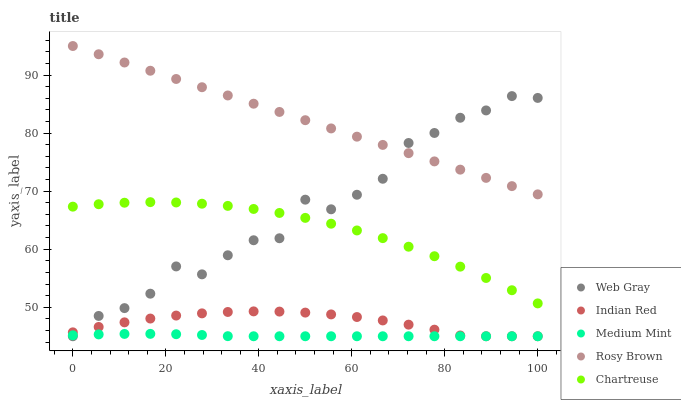Does Medium Mint have the minimum area under the curve?
Answer yes or no. Yes. Does Rosy Brown have the maximum area under the curve?
Answer yes or no. Yes. Does Web Gray have the minimum area under the curve?
Answer yes or no. No. Does Web Gray have the maximum area under the curve?
Answer yes or no. No. Is Rosy Brown the smoothest?
Answer yes or no. Yes. Is Web Gray the roughest?
Answer yes or no. Yes. Is Web Gray the smoothest?
Answer yes or no. No. Is Rosy Brown the roughest?
Answer yes or no. No. Does Medium Mint have the lowest value?
Answer yes or no. Yes. Does Rosy Brown have the lowest value?
Answer yes or no. No. Does Rosy Brown have the highest value?
Answer yes or no. Yes. Does Web Gray have the highest value?
Answer yes or no. No. Is Medium Mint less than Chartreuse?
Answer yes or no. Yes. Is Chartreuse greater than Indian Red?
Answer yes or no. Yes. Does Indian Red intersect Web Gray?
Answer yes or no. Yes. Is Indian Red less than Web Gray?
Answer yes or no. No. Is Indian Red greater than Web Gray?
Answer yes or no. No. Does Medium Mint intersect Chartreuse?
Answer yes or no. No. 